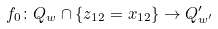Convert formula to latex. <formula><loc_0><loc_0><loc_500><loc_500>f _ { 0 } \colon Q _ { w } \cap \{ z _ { 1 2 } = x _ { 1 2 } \} \to Q ^ { \prime } _ { w ^ { \prime } }</formula> 